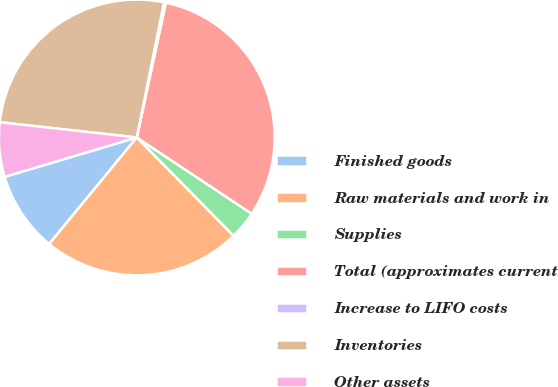<chart> <loc_0><loc_0><loc_500><loc_500><pie_chart><fcel>Finished goods<fcel>Raw materials and work in<fcel>Supplies<fcel>Total (approximates current<fcel>Increase to LIFO costs<fcel>Inventories<fcel>Other assets<nl><fcel>9.44%<fcel>23.33%<fcel>3.3%<fcel>30.94%<fcel>0.22%<fcel>26.4%<fcel>6.37%<nl></chart> 